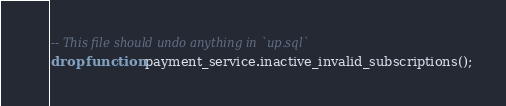<code> <loc_0><loc_0><loc_500><loc_500><_SQL_>-- This file should undo anything in `up.sql`
drop function payment_service.inactive_invalid_subscriptions();</code> 